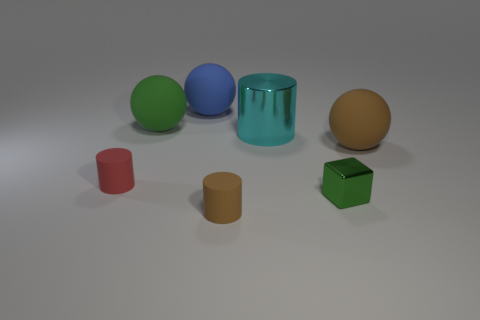What number of big objects are either brown matte spheres or green matte balls?
Provide a short and direct response. 2. Is the number of tiny brown things behind the small metal block less than the number of brown rubber balls that are behind the blue sphere?
Your answer should be compact. No. What number of objects are small green shiny cubes or cyan cylinders?
Keep it short and to the point. 2. There is a cyan metal thing; how many big blue rubber things are behind it?
Ensure brevity in your answer.  1. Do the tiny metal block and the big shiny cylinder have the same color?
Provide a succinct answer. No. What is the shape of the other tiny object that is made of the same material as the tiny brown thing?
Offer a very short reply. Cylinder. Does the metallic object that is in front of the big cyan thing have the same shape as the cyan thing?
Keep it short and to the point. No. What number of gray objects are either tiny objects or tiny rubber cylinders?
Your response must be concise. 0. Are there the same number of cyan metal objects behind the tiny brown matte object and rubber spheres in front of the large blue matte sphere?
Ensure brevity in your answer.  No. The small cylinder behind the tiny matte cylinder to the right of the green matte sphere on the left side of the blue sphere is what color?
Your response must be concise. Red. 